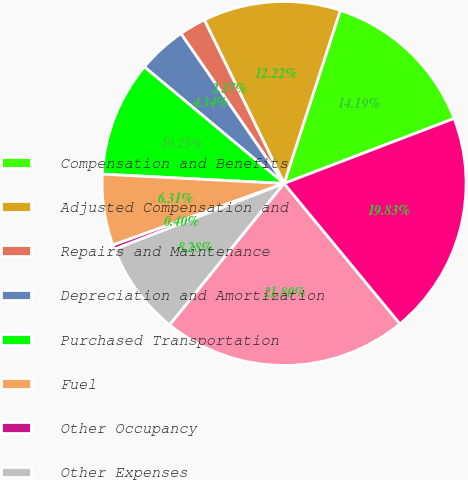Convert chart. <chart><loc_0><loc_0><loc_500><loc_500><pie_chart><fcel>Compensation and Benefits<fcel>Adjusted Compensation and<fcel>Repairs and Maintenance<fcel>Depreciation and Amortization<fcel>Purchased Transportation<fcel>Fuel<fcel>Other Occupancy<fcel>Other Expenses<fcel>Total Operating Expenses<fcel>Adjusted Total Operating<nl><fcel>14.19%<fcel>12.22%<fcel>2.37%<fcel>4.34%<fcel>10.25%<fcel>6.31%<fcel>0.4%<fcel>8.28%<fcel>21.8%<fcel>19.83%<nl></chart> 